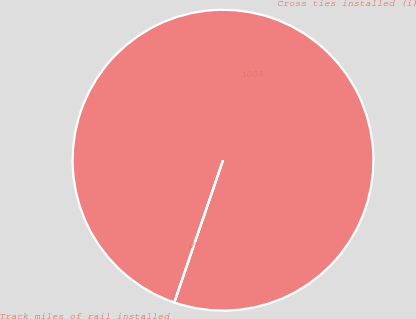Convert chart. <chart><loc_0><loc_0><loc_500><loc_500><pie_chart><fcel>Track miles of rail installed<fcel>Cross ties installed (i)<nl><fcel>0.01%<fcel>99.99%<nl></chart> 